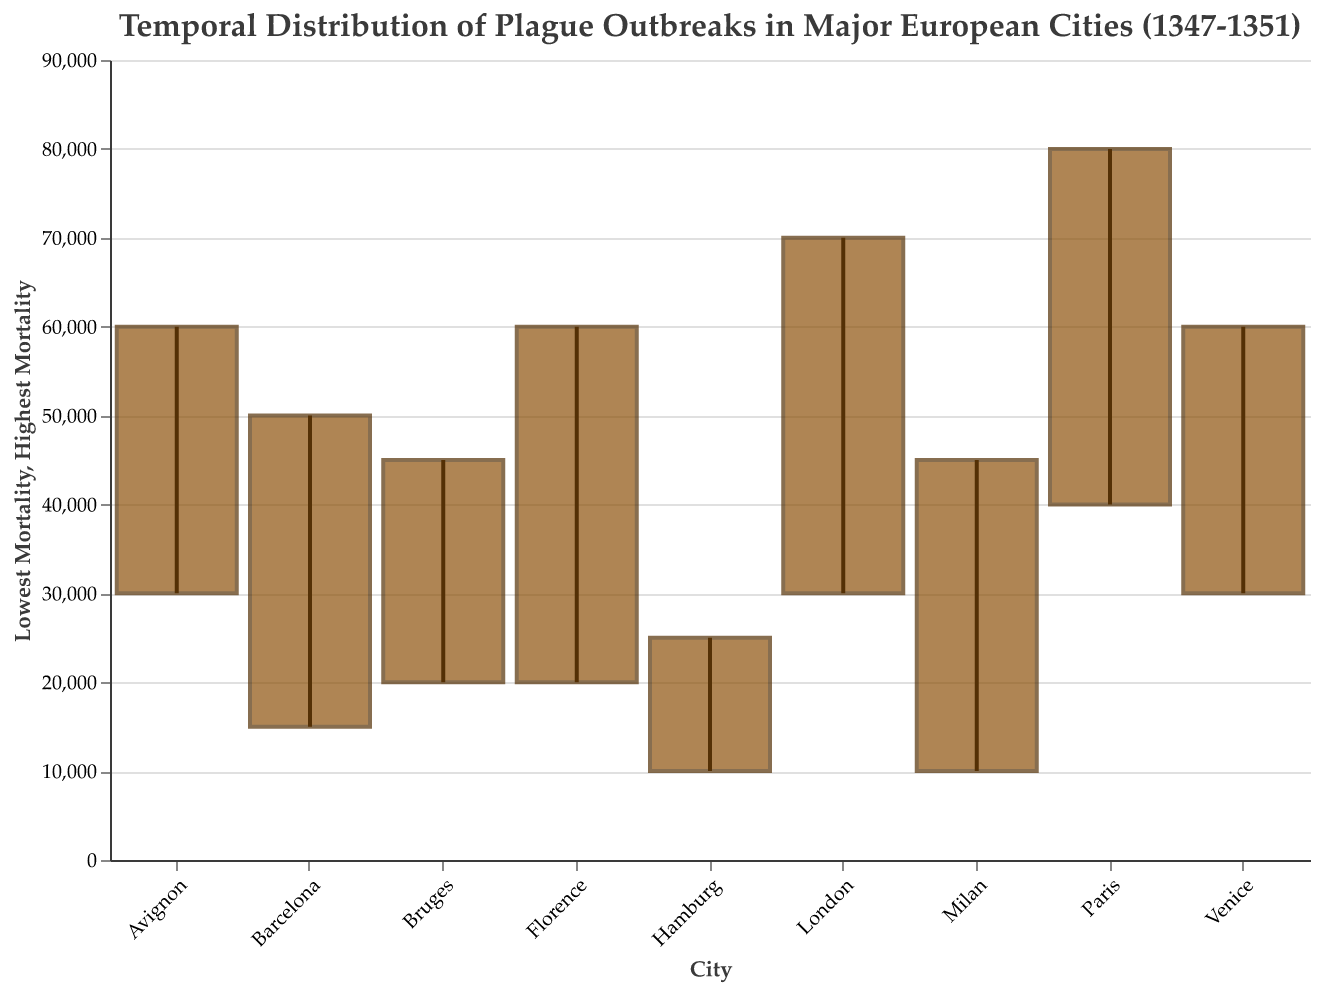What is the title of the plot? The title of the plot is situated at the top of the figure, often in a larger font size and different style to make it stand out. Here, it reads: "Temporal Distribution of Plague Outbreaks in Major European Cities (1347-1351)."
Answer: Temporal Distribution of Plague Outbreaks in Major European Cities (1347-1351) Which city experienced the highest mortality during the plague outbreaks? To determine the city with the highest mortality, look for the highest value on the y-axis. The highest mortality bar length implies the top point on the y-axis. In this case, the city with the highest mortality is Paris with a range reaching 80000.
Answer: Paris What are the start and end dates for the plague outbreak in London? Locate the bar associated with London on the x-axis, then refer to the dates presented in the dataset for this city. London experienced the outbreak from 1348-09-01 to 1350-01-31.
Answer: 1348-09-01 to 1350-01-31 How does the plague duration in Venice compare to that in Florence? To compare the durations, calculate the number of days between the Start Date and the End Date for both cities using a standard calendar conversion. Florence: 1348-04-30 - 1347-03-01 = 425 days. Venice: 1348-09-15 - 1348-01-15 = 243 days. Florence's plague duration is longer.
Answer: Florence's duration is longer What is the range of mortality (difference between highest and lowest mortality) in Milan? Find the highest and lowest mortality points for Milan on the y-axis and calculate the difference: 45000 - 10000 = 35000.
Answer: 35000 Compare the lowest mortality figures between Barcelona and Bruges. Which city had the lower figure? Look at the lengths of the bottom ends of the bars for both cities on the y-axis for lowest mortality. Barcelona has the lower figure with 15000 compared to 20000 in Bruges.
Answer: Barcelona Which city had the shortest plague outbreak duration, and what was that duration? Compare the durations (calculated as end date minus start date) for all cities. Venice has the shortest duration: 1348-09-15 to 1348-01-15, which is 243 days.
Answer: Venice, 243 days What is the average highest mortality across Paris, London, and Avignon? Sum the highest mortality values for Paris (80000), London (70000), and Avignon (60000) and divide by the number of cities: (80000 + 70000 + 60000) / 3 = 70000.
Answer: 70000 Identify the city that had the smallest range of mortality and specify what that range was. The smallest range can be found by calculating the difference between highest and lowest mortalities for each city and identifying the smallest. Hamburg: 25000 - 10000 = 15000, which is the smallest range.
Answer: Hamburg, 15000 Which city had a plague outbreak start after 1349-01-01 and what was its start date? Identify cities with start dates post-1349-01-01 from the dataset provided. Milan’s outbreak started on 1349-02-01.
Answer: Milan, 1349-02-01 